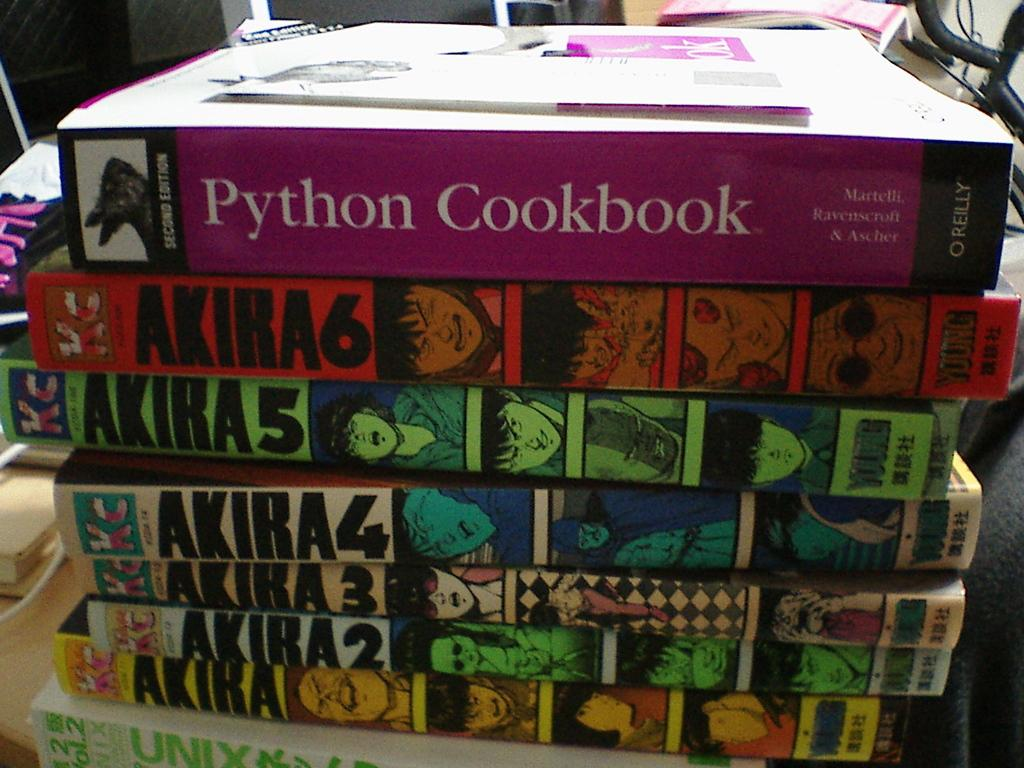<image>
Give a short and clear explanation of the subsequent image. A collection of Akira books and the Python Cookbook. 